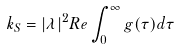Convert formula to latex. <formula><loc_0><loc_0><loc_500><loc_500>k _ { S } = | \lambda | ^ { 2 } R e \int _ { 0 } ^ { \infty } g ( \tau ) d \tau</formula> 